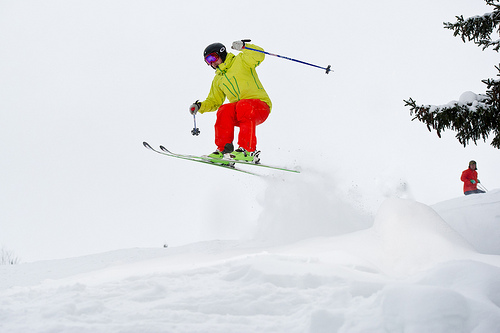Can you describe the environment surrounding the skier? The skier is surrounded by a tranquil, snowy landscape with evergreen trees partially covered in snow, creating an idyllic setting for winter sports enthusiasts. 